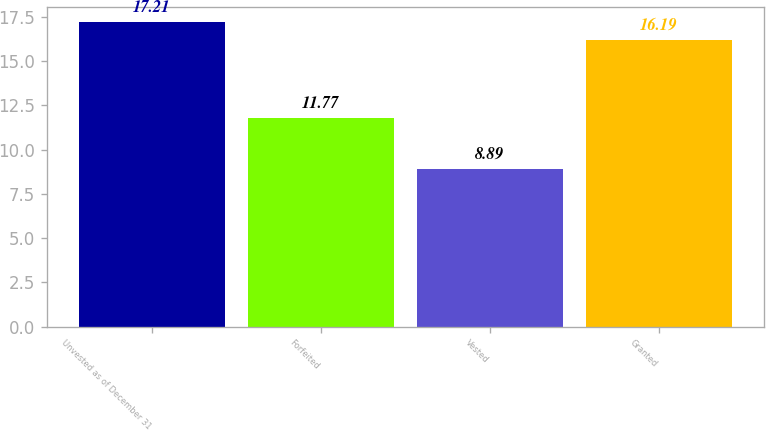Convert chart. <chart><loc_0><loc_0><loc_500><loc_500><bar_chart><fcel>Unvested as of December 31<fcel>Forfeited<fcel>Vested<fcel>Granted<nl><fcel>17.21<fcel>11.77<fcel>8.89<fcel>16.19<nl></chart> 